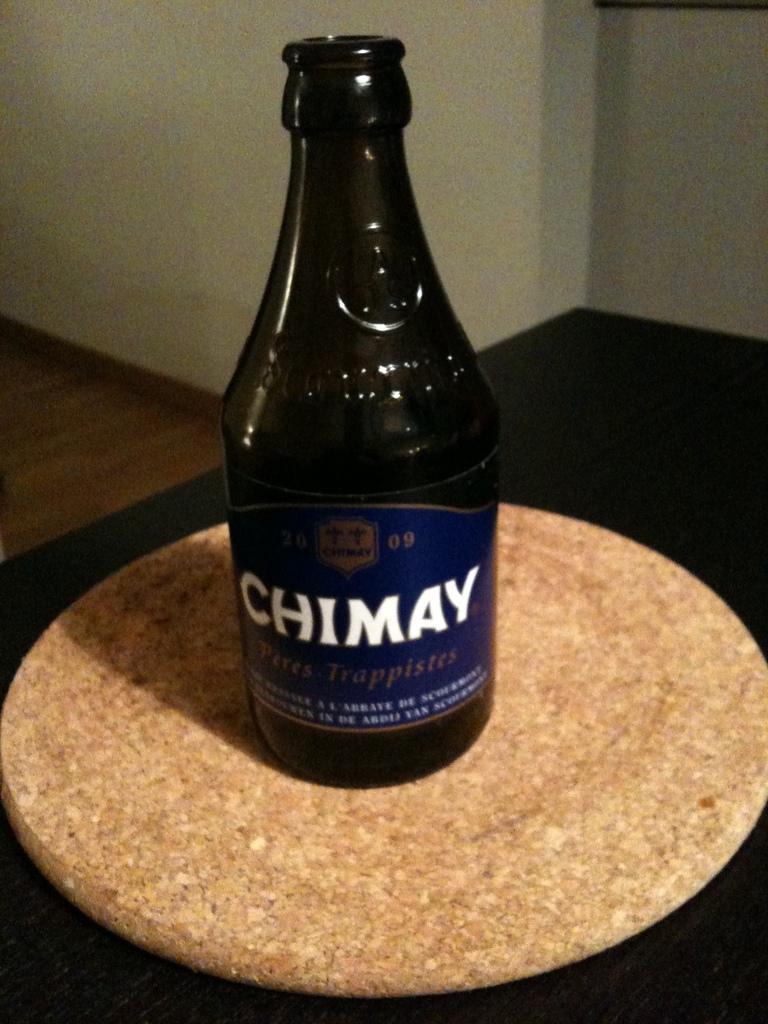Is the chimay bottle empty?
Make the answer very short. Answering does not require reading text in the image. What year is on the bottle?
Offer a very short reply. 2009. 